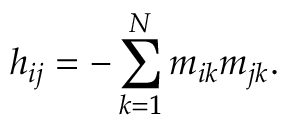<formula> <loc_0><loc_0><loc_500><loc_500>h _ { i j } = - \sum _ { k = 1 } ^ { N } m _ { i k } m _ { j k } .</formula> 